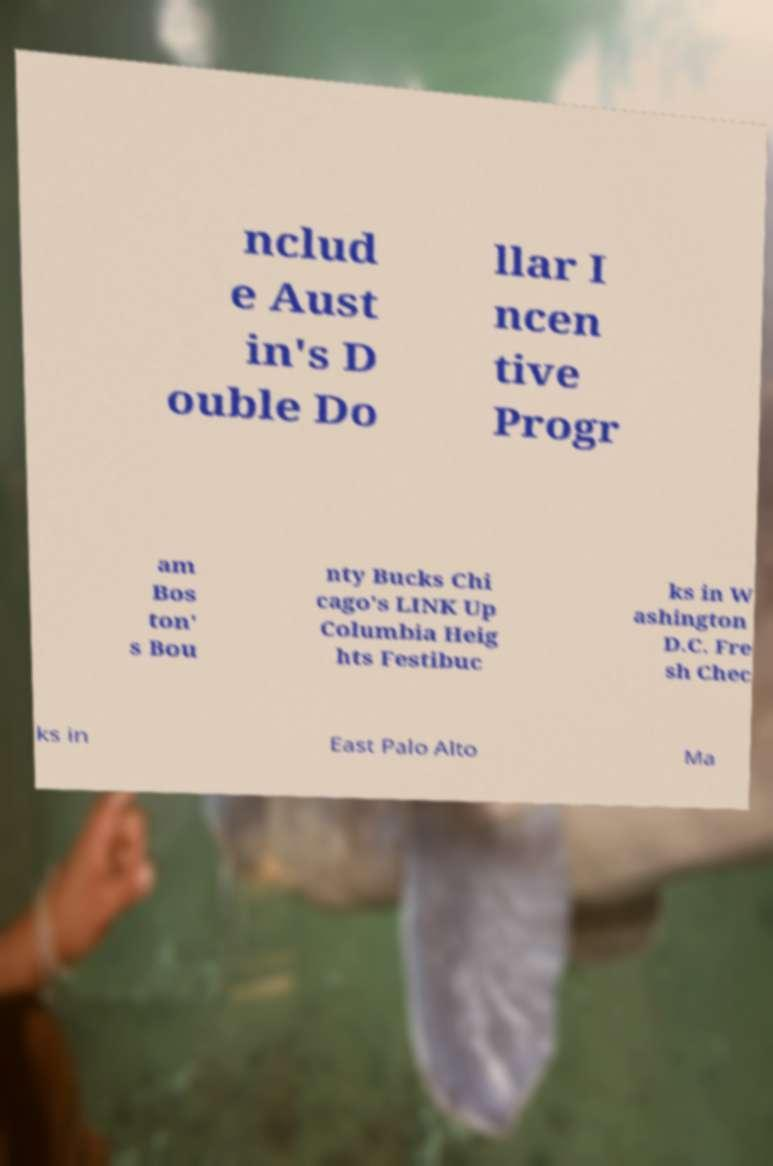There's text embedded in this image that I need extracted. Can you transcribe it verbatim? nclud e Aust in's D ouble Do llar I ncen tive Progr am Bos ton' s Bou nty Bucks Chi cago's LINK Up Columbia Heig hts Festibuc ks in W ashington D.C. Fre sh Chec ks in East Palo Alto Ma 